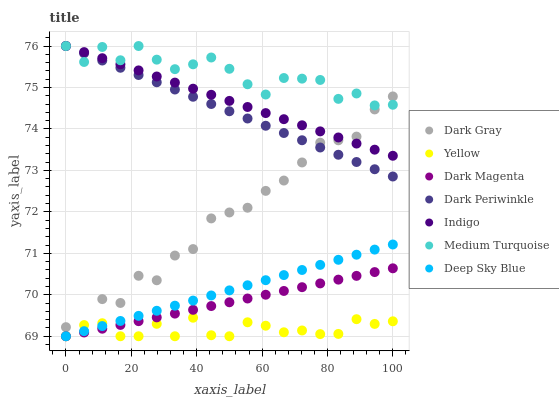Does Yellow have the minimum area under the curve?
Answer yes or no. Yes. Does Medium Turquoise have the maximum area under the curve?
Answer yes or no. Yes. Does Dark Magenta have the minimum area under the curve?
Answer yes or no. No. Does Dark Magenta have the maximum area under the curve?
Answer yes or no. No. Is Dark Periwinkle the smoothest?
Answer yes or no. Yes. Is Dark Gray the roughest?
Answer yes or no. Yes. Is Dark Magenta the smoothest?
Answer yes or no. No. Is Dark Magenta the roughest?
Answer yes or no. No. Does Dark Magenta have the lowest value?
Answer yes or no. Yes. Does Dark Gray have the lowest value?
Answer yes or no. No. Does Dark Periwinkle have the highest value?
Answer yes or no. Yes. Does Dark Magenta have the highest value?
Answer yes or no. No. Is Dark Magenta less than Medium Turquoise?
Answer yes or no. Yes. Is Dark Periwinkle greater than Dark Magenta?
Answer yes or no. Yes. Does Medium Turquoise intersect Dark Periwinkle?
Answer yes or no. Yes. Is Medium Turquoise less than Dark Periwinkle?
Answer yes or no. No. Is Medium Turquoise greater than Dark Periwinkle?
Answer yes or no. No. Does Dark Magenta intersect Medium Turquoise?
Answer yes or no. No. 